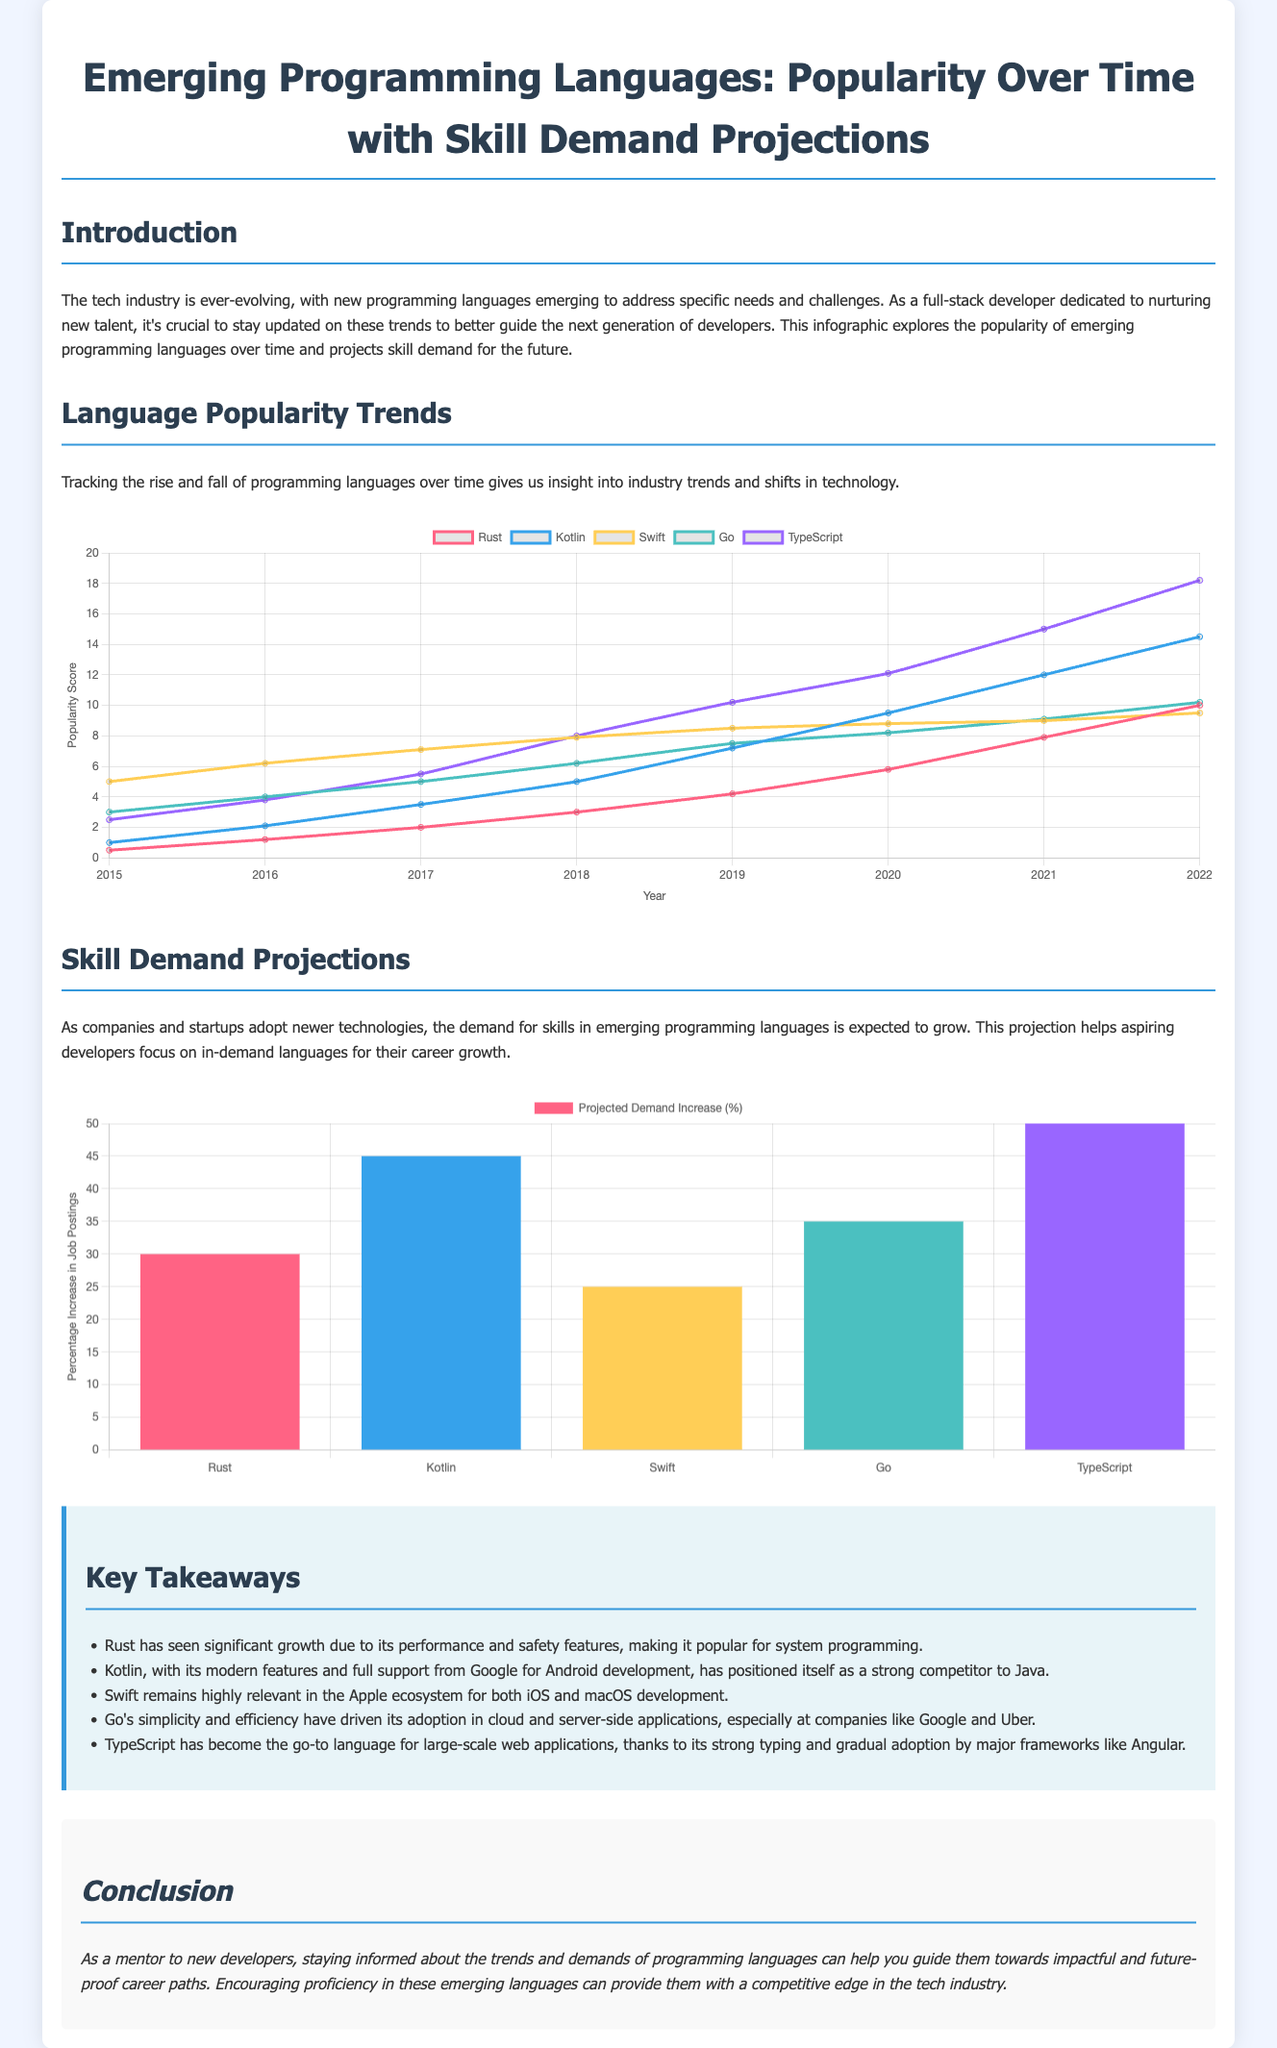what programming language showed the highest popularity score in 2022? In 2022, looking at the popularity chart, the language with the highest score was Kotlin with a score of 14.5.
Answer: Kotlin which programming language has the lowest popularity score in 2015? The popularity chart shows that in 2015, Rust had the lowest popularity score, which was 0.5.
Answer: Rust what is the projected demand increase percentage for TypeScript? The demand chart indicates a projected increase of 50% for TypeScript.
Answer: 50 which language is noted for its performance and safety features? The key takeaways section mentions Rust as the language known for its performance and safety features.
Answer: Rust which two programming languages are positioned as competitors concerning Android development? The information indicates that Kotlin and Java are positioned as competitors in Android development.
Answer: Kotlin and Java what year did Swift have a popularity score of 7.9? According to the popularity chart, Swift had a score of 7.9 in 2018.
Answer: 2018 how many programming languages are represented in the demand chart? The demand chart lists five programming languages.
Answer: five which language is highlighted for its role in cloud and server-side applications? Go is highlighted for its adoption in cloud and server-side applications, particularly at companies like Google and Uber.
Answer: Go 